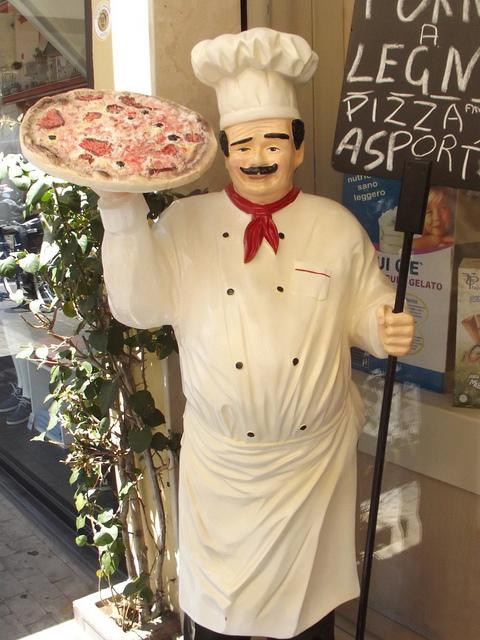What is the statue holding?

Choices:
A) torch
B) pizza
C) television
D) plunger pizza 